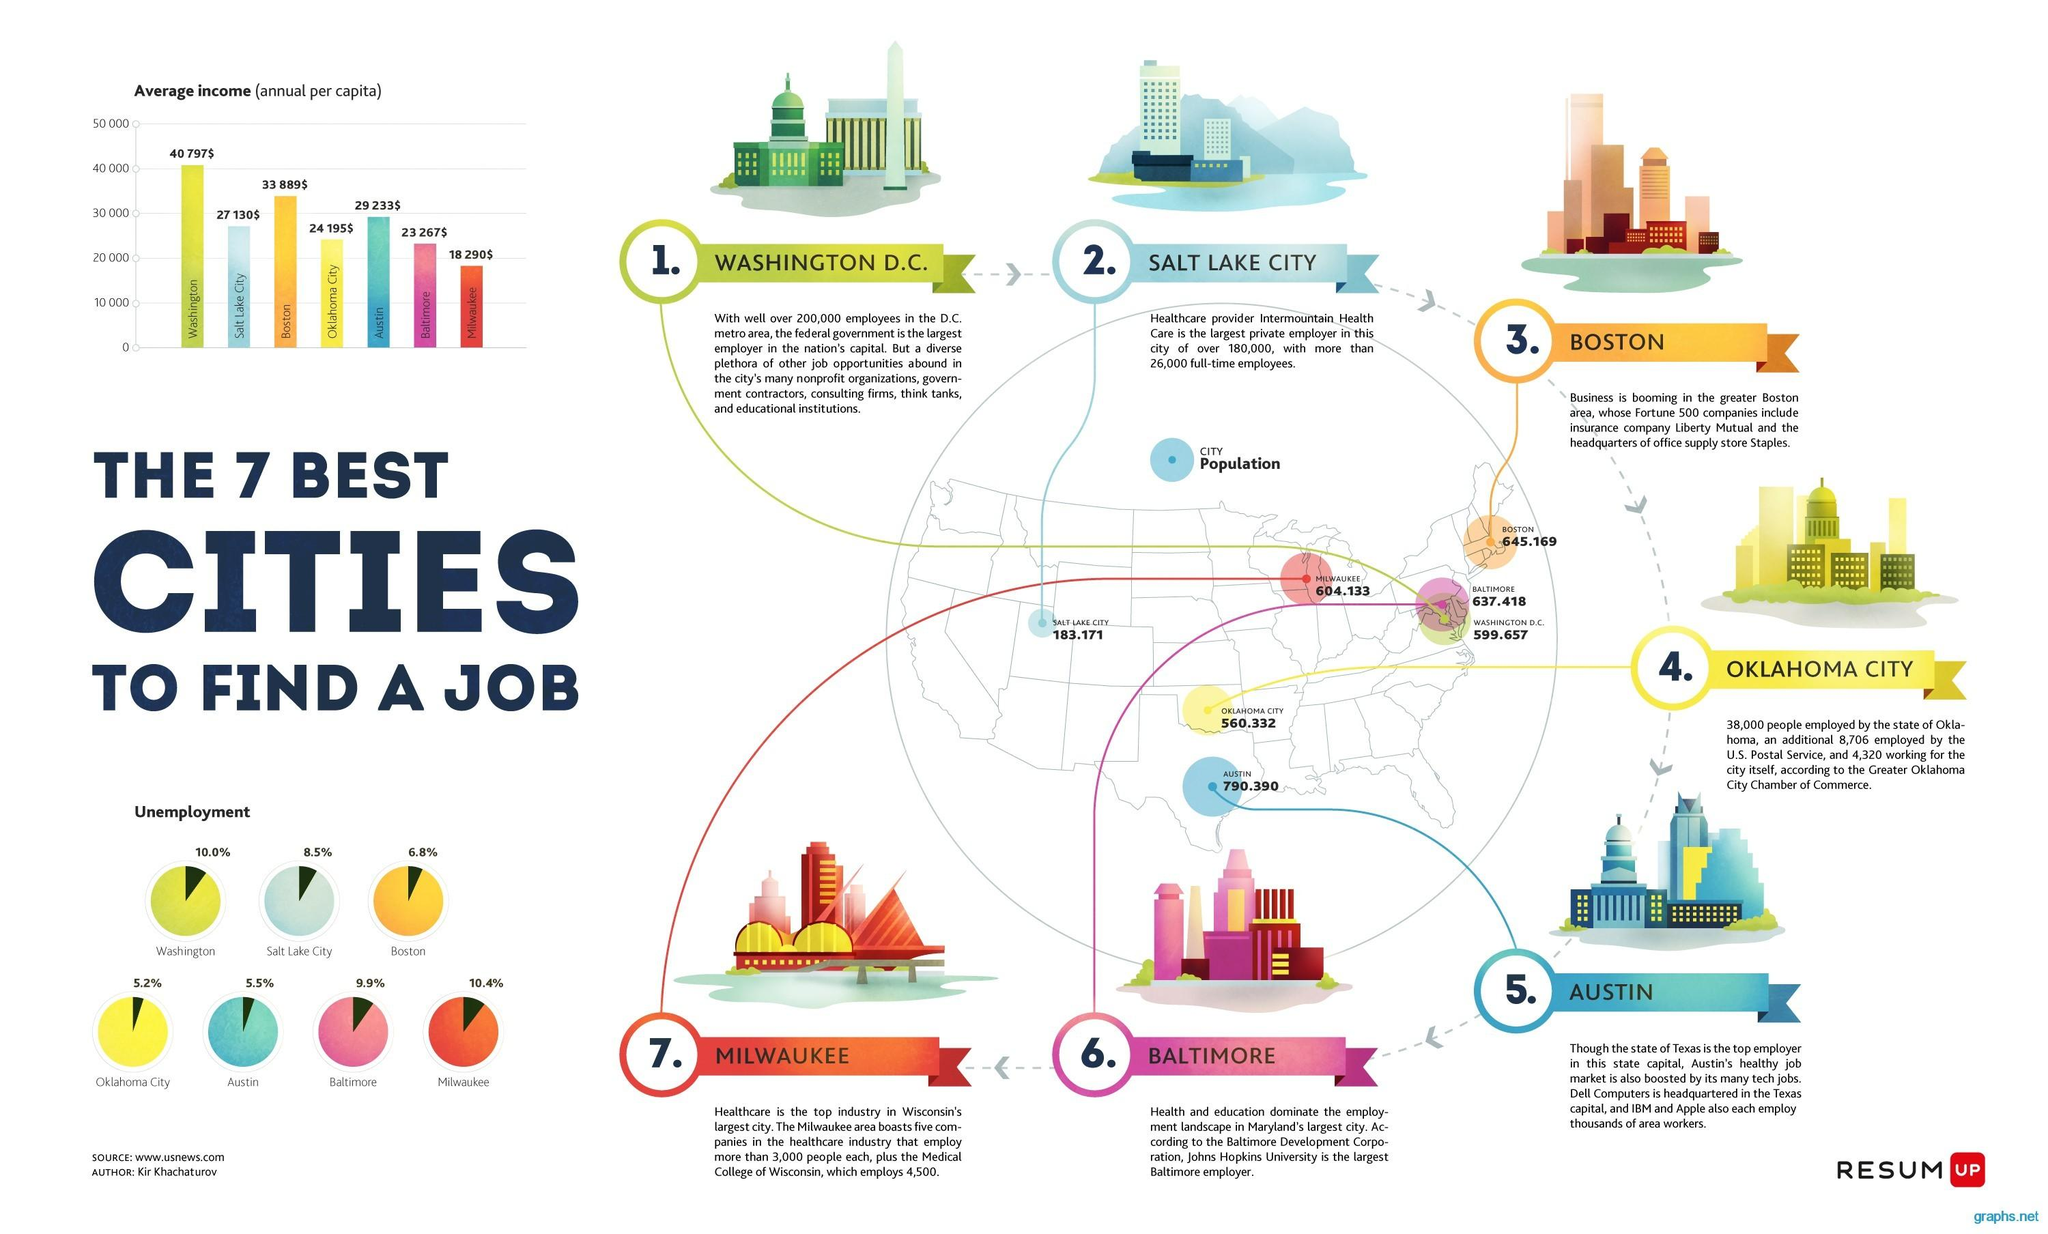Mention a couple of crucial points in this snapshot. According to the data, the employment rate in the state of Washington is 90.0%. According to the information, Boston has an employment percentage of 93.2%. According to recent statistics, the employment rate in Austin is 94.5%. 